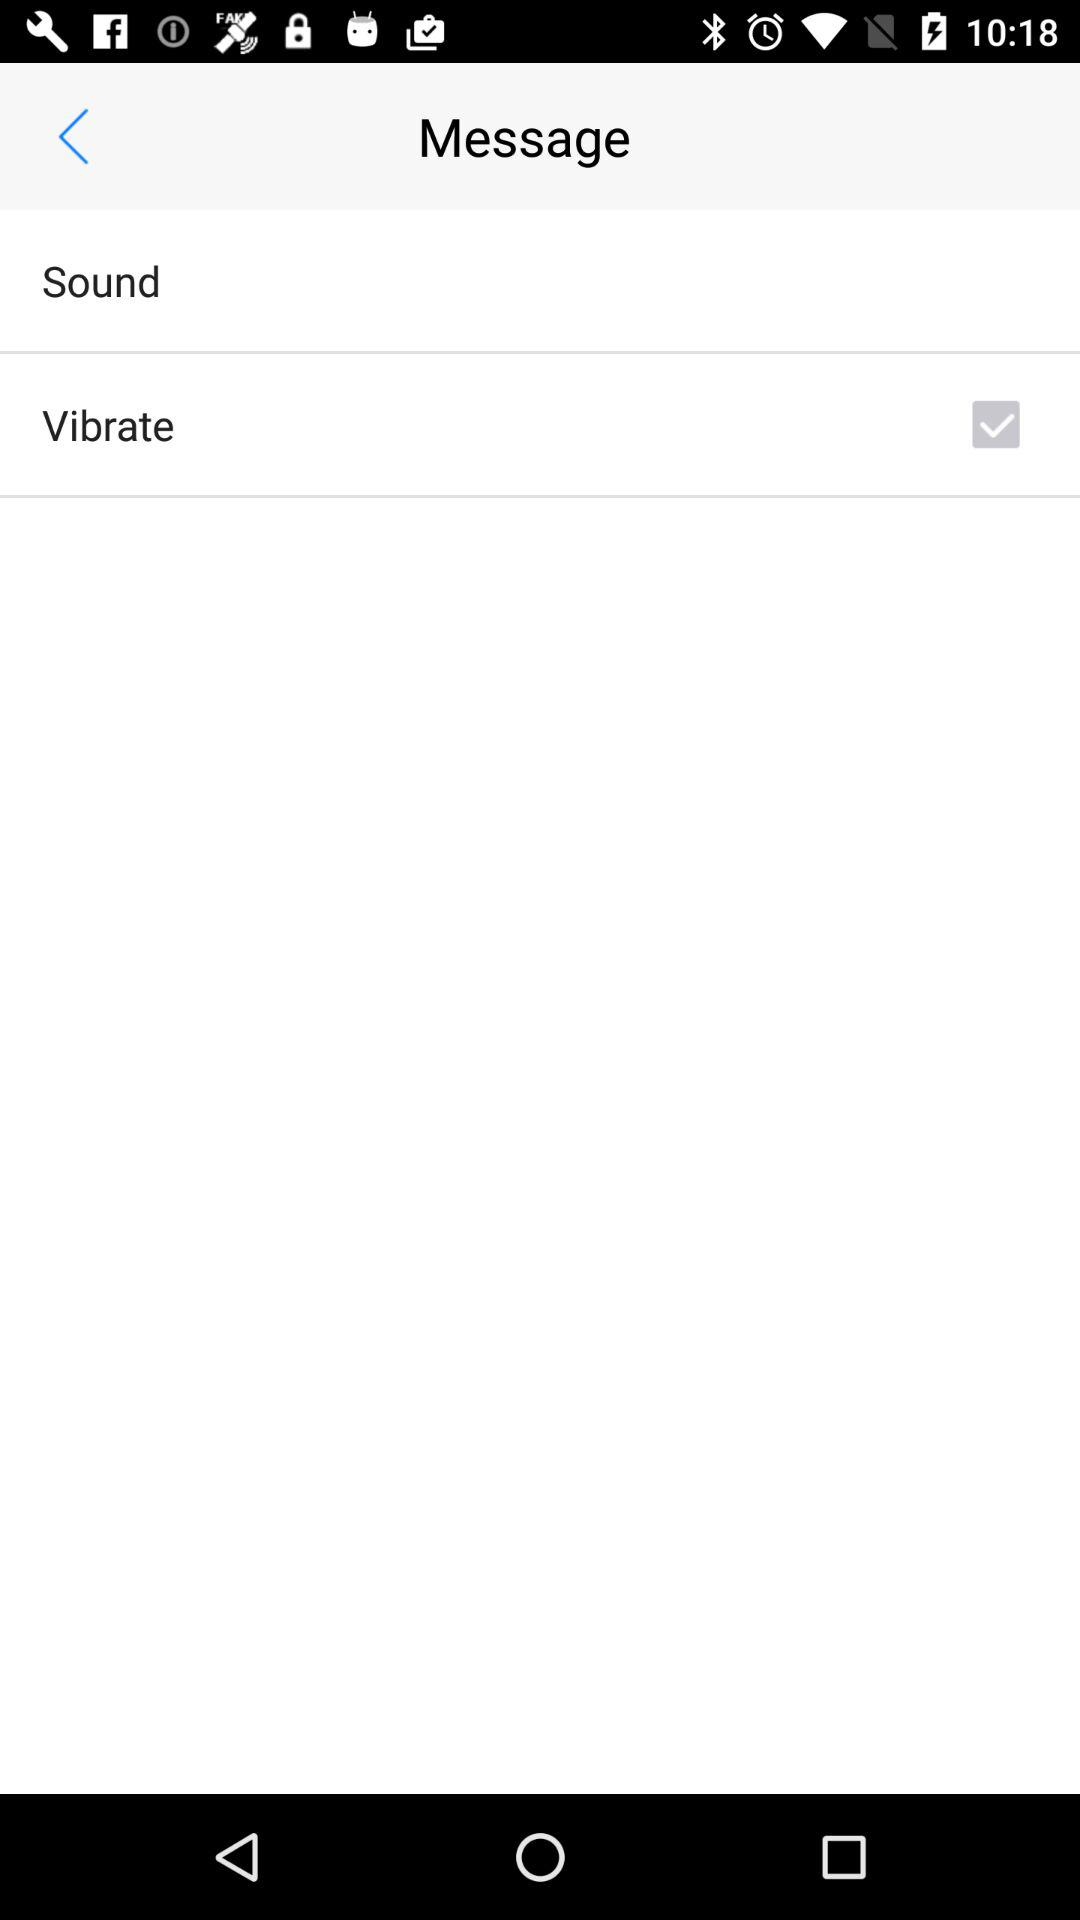What is the selected option in the message? The selected option in the message is Vibrate. 